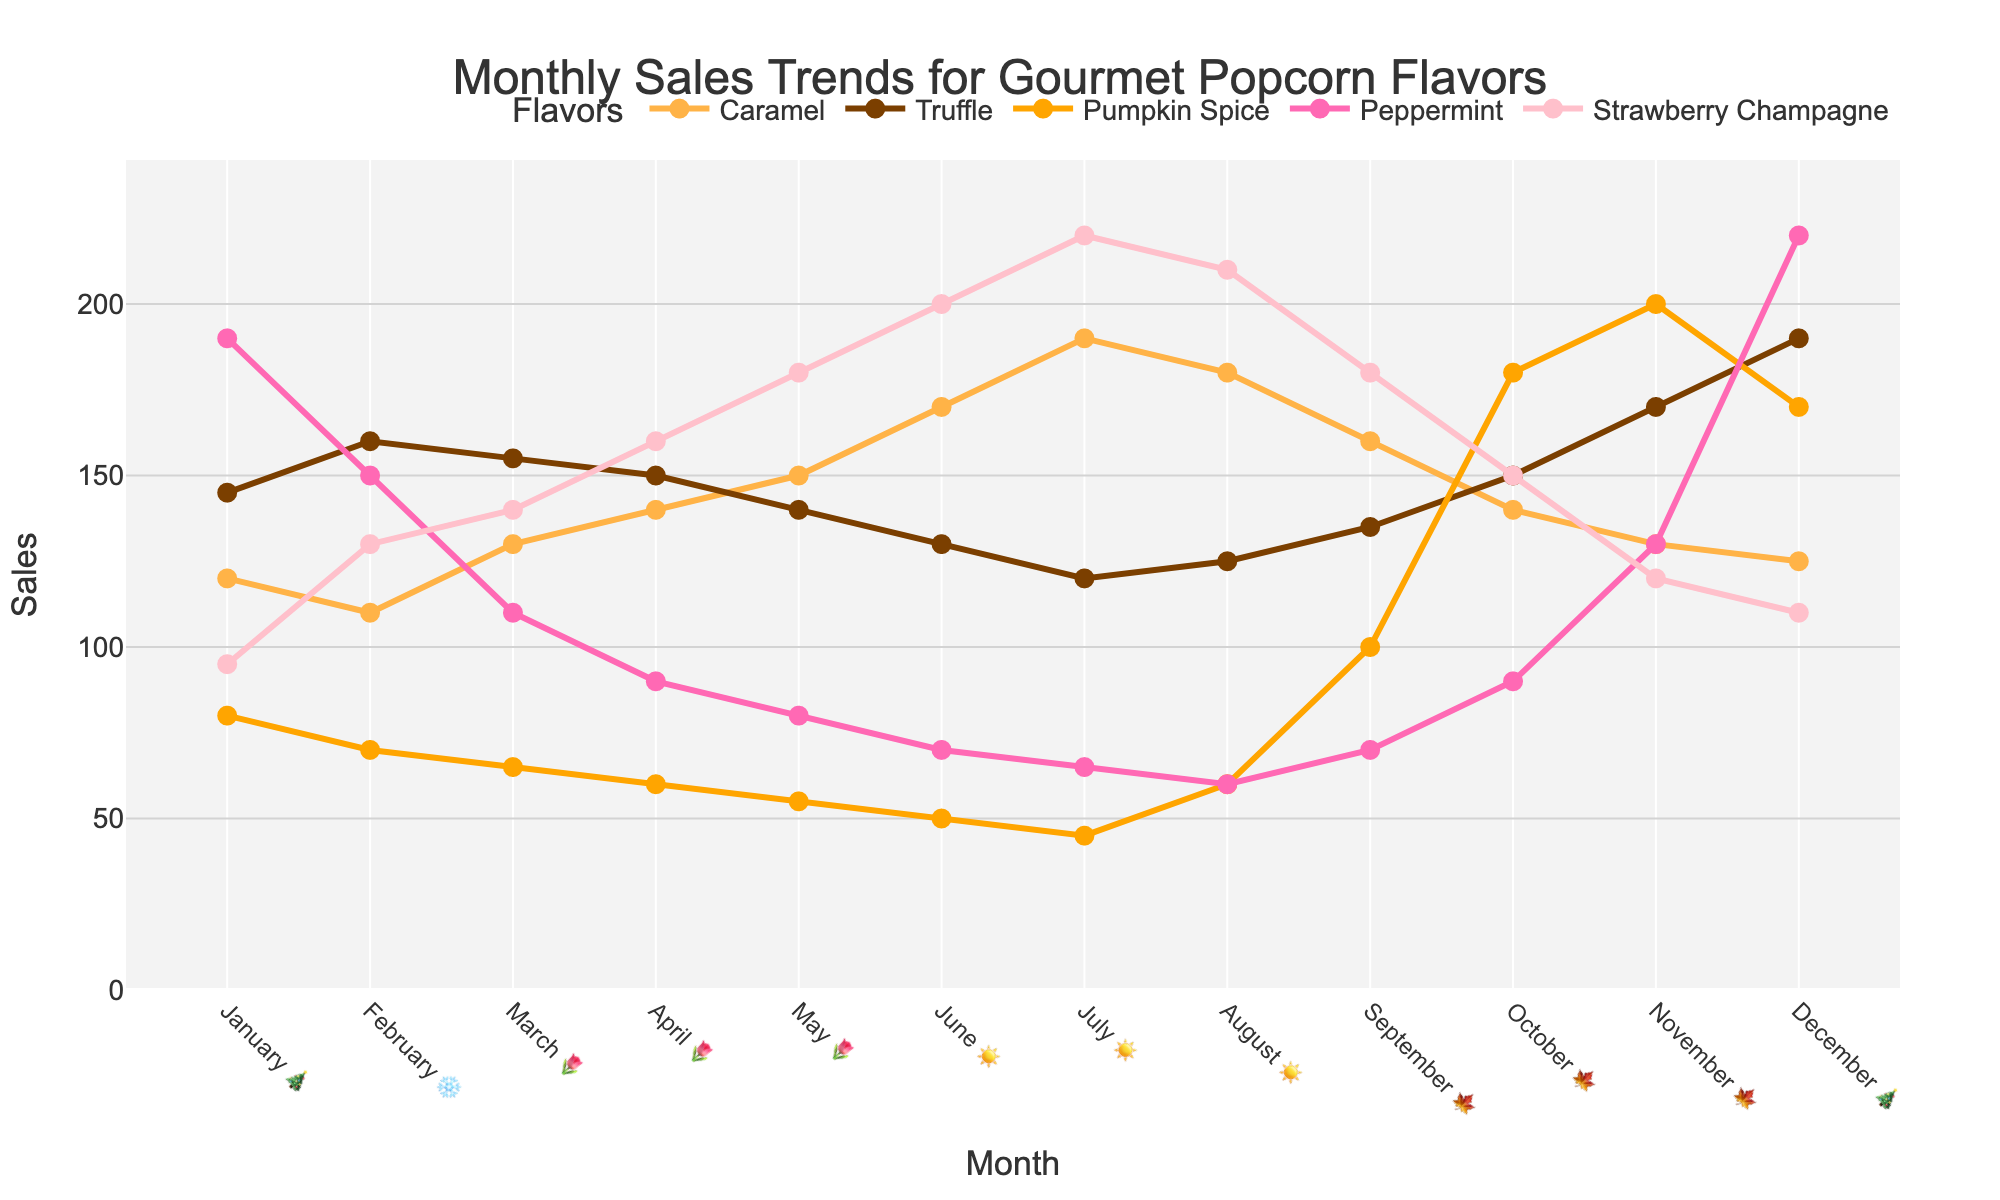Which month had the highest sales for Strawberry Champagne? Observe the data points for the Strawberry Champagne line. The highest point is in July.
Answer: July Which flavor had the lowest sales in January? Look at the January data for all flavors. Pumpkin Spice has the lowest sales at 80.
Answer: Pumpkin Spice What is the difference in sales between Caramel and Peppermint in December? In December, Caramel sales are 125, and Peppermint sales are 220. The difference is 220 - 125.
Answer: 95 Which flavor shows a peak in sales during the fall months (🍁)? Observing the fall months (September, October, November), Pumpkin Spice has a clear increase in sales, peaking in October and November.
Answer: Pumpkin Spice Are there any flavors that show a consistent upward trend throughout the year? Review the trend lines for each flavor. Strawberry Champagne consistently increases from January to July.
Answer: Strawberry Champagne During which month do Caramel and Truffle sales intersect? Look for the point where the Caramel and Truffle lines cross. They intersect around November.
Answer: November Which month has the lowest sales for Peppermint? Observing the Peppermint data points, the lowest sales occur in July.
Answer: July What is the total sales for Truffle in the spring months (🌷)? Sum up the Truffle sales in March, April, and May: 155 + 150 + 140.
Answer: 445 How do the sales of Caramel change from June to July? Caramel sales increase from 170 in June to 190 in July.
Answer: Increase Which flavor has the most significant drop in sales between two consecutive months? Find the largest drop between consecutive months for any flavor. Peppermint drops from 220 in December to 150 in January, a drop of 70.
Answer: Peppermint 